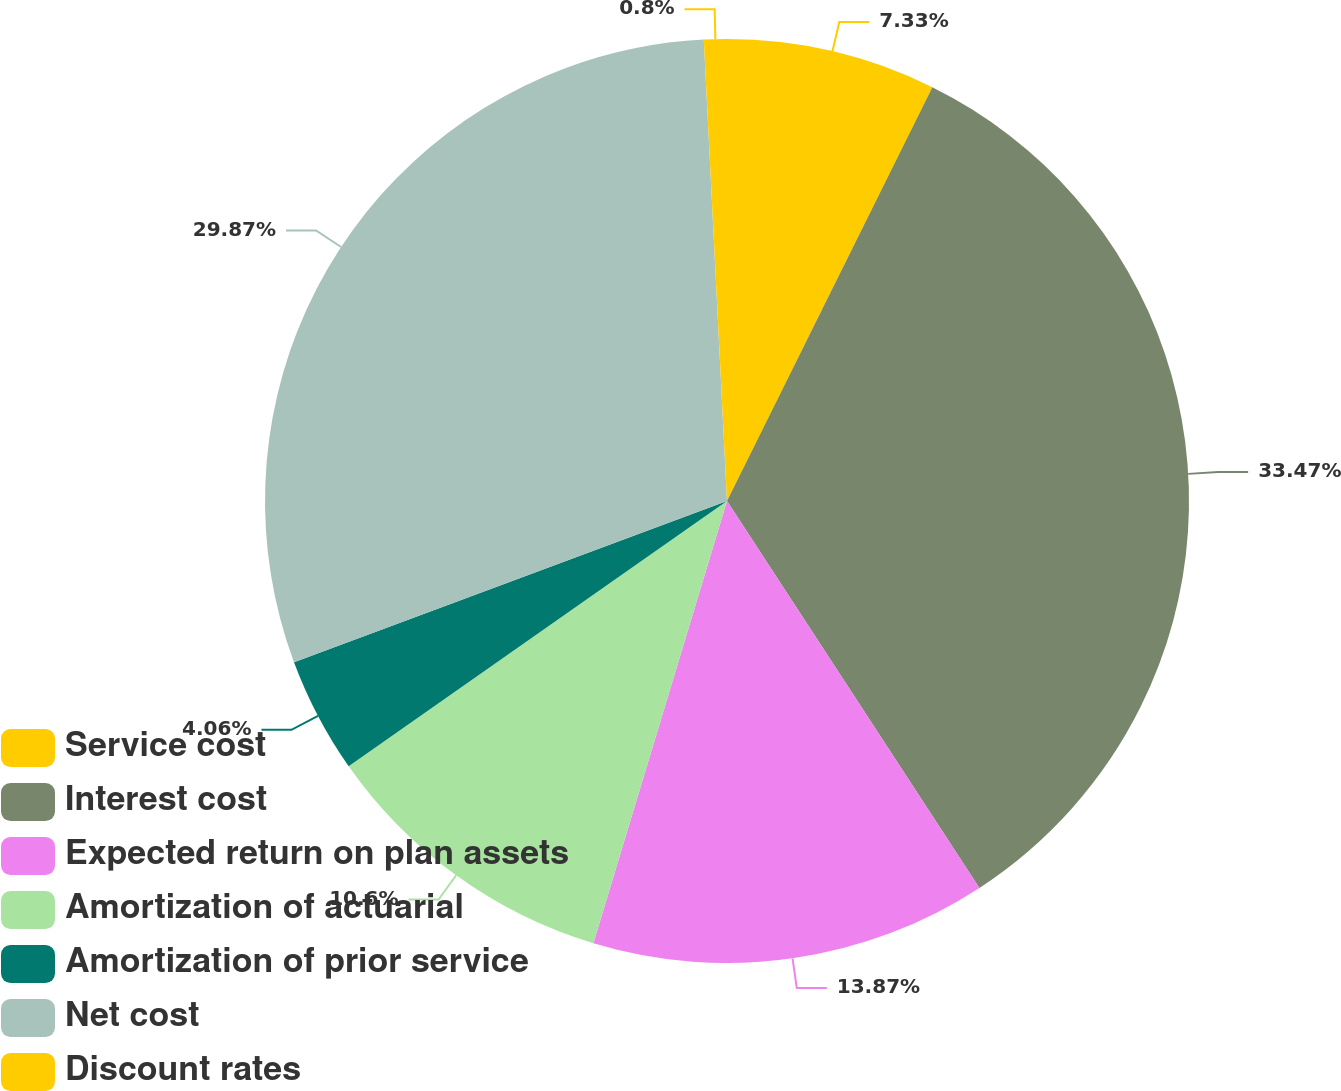<chart> <loc_0><loc_0><loc_500><loc_500><pie_chart><fcel>Service cost<fcel>Interest cost<fcel>Expected return on plan assets<fcel>Amortization of actuarial<fcel>Amortization of prior service<fcel>Net cost<fcel>Discount rates<nl><fcel>7.33%<fcel>33.47%<fcel>13.87%<fcel>10.6%<fcel>4.06%<fcel>29.87%<fcel>0.8%<nl></chart> 